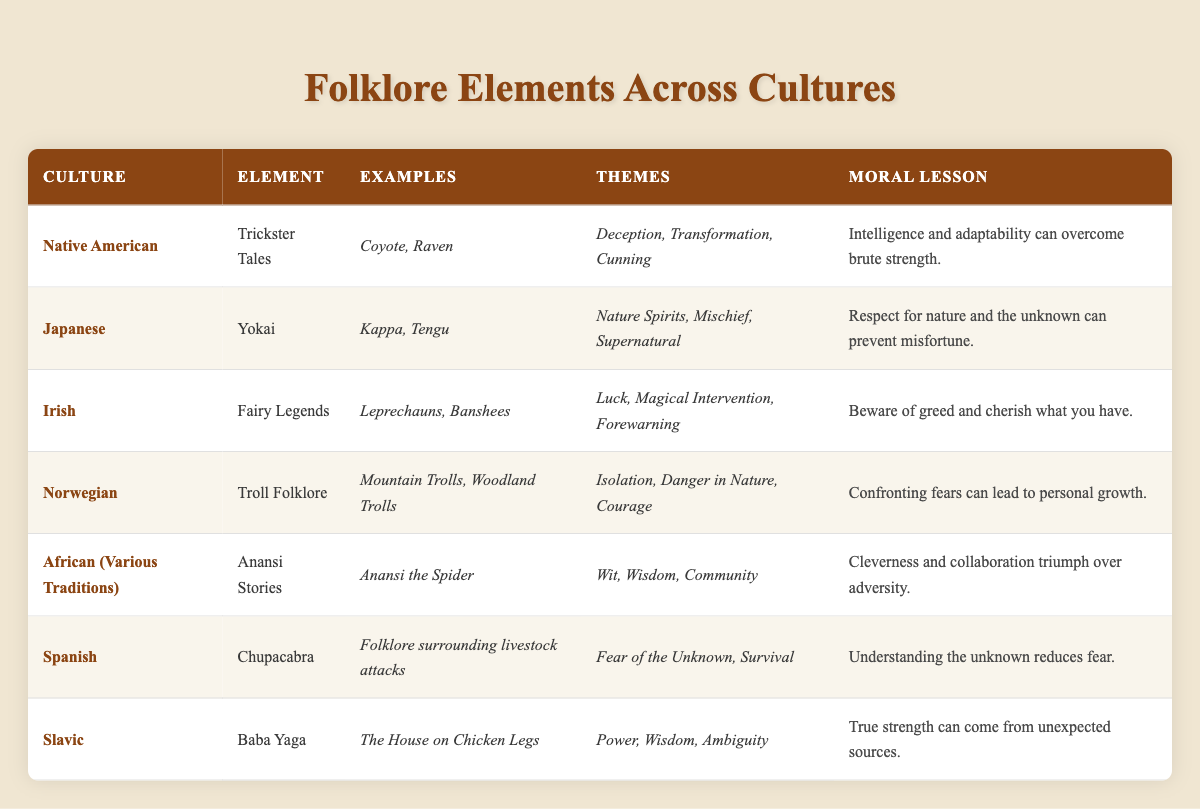What artistic element is found in Native American folklore? The table lists "Trickster Tales" as the folklore element of the Native American culture.
Answer: Trickster Tales Which culture's folklore emphasizes respect for nature and the unknown? Looking at the "Moral Lesson" column for the Japanese culture, it states that one should respect nature and the unknown to prevent misfortune.
Answer: Japanese Do all cultures represented have both themes and examples specified? By examining the table, each row contains both a "Themes" and "Examples" entry, confirming that they all are present.
Answer: Yes What moral lesson does the Irish folklore impart? The table entry for Irish folklore lists the moral lesson as "Beware of greed and cherish what you have."
Answer: Beware of greed and cherish what you have Is there a folklore element among the cultures that reflects community wisdom? The entry for African folklore highlights "Anansi Stories," focusing on wit, wisdom, and community; therefore, it confirms this cultural aspect.
Answer: Yes What is the common theme across both Norwegian and Slavic folklore? Both cultures' entries include themes related to strength and courage; Norwegian folklore mentions "Courage," while Slavic folklore suggests "True strength."
Answer: Strength and courage Which culture's folklore incorporates characters like Kappa and Tengu? The "Examples" column for Japanese folklore includes Kappa and Tengu as characters representing the Yokai element.
Answer: Japanese How many unique themes are mentioned in the entire table? Counting through the "Themes" column for each culture yields the following unique themes: Deception, Transformation, Cunning, Nature Spirits, Mischief, Supernatural, Luck, Magical Intervention, Forewarning, Isolation, Danger in Nature, Courage, Wit, Wisdom, Community, Fear of the Unknown, Survival, Power, and Ambiguity, totaling 17 unique themes.
Answer: 17 What is the relationship between the examples given in folklore and their respective moral lessons? Each folklore's "Examples" directly relates to its "Moral Lesson" by reflecting cultural beliefs; for instance, "Anansi Stories" in African culture illustrates how cleverness triumphs over adversity, aligning examples of wit and community with moral teachings.
Answer: They directly reflect cultural beliefs 